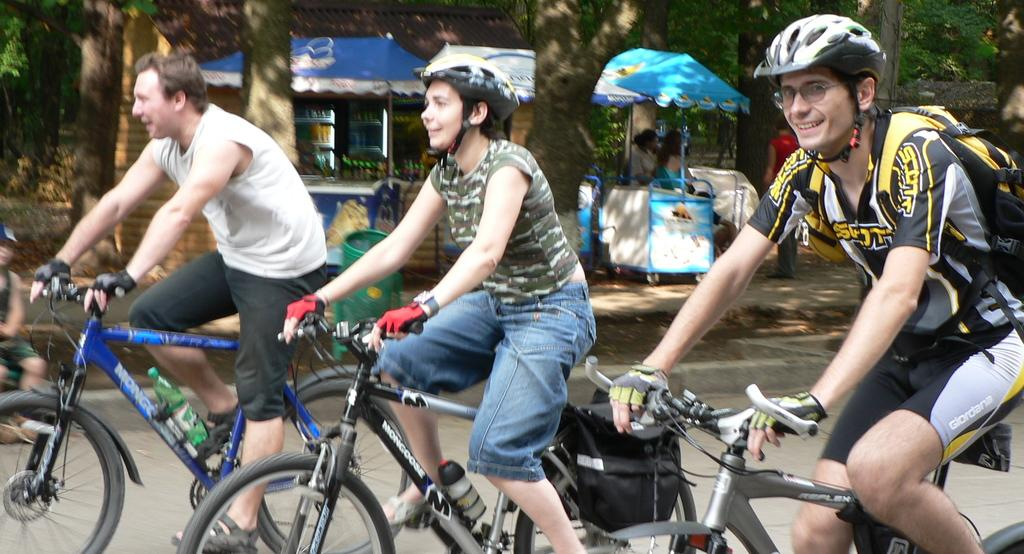How many people are riding bicycles in the image? There are 3 people riding bicycles in the image. Are any of the cyclists wearing helmets? Yes, the last two people are wearing helmets. What can be seen in the background of the image? There are small stores and trees visible in the background. Can you describe the person sitting on the left side of the image? There is a person sitting on the left side of the image, but no specific details about their appearance or clothing are provided. What type of fruit is being sold by the slaves in the image? There are no slaves or fruit present in the image; it features people riding bicycles and a background with small stores and trees. 